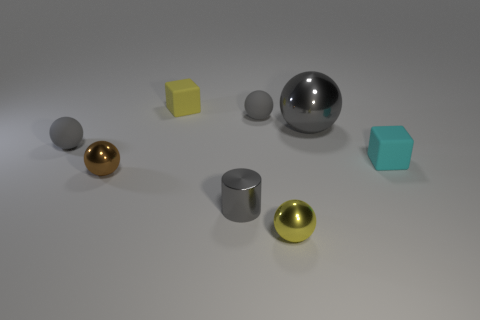What number of things are either large gray metal balls or tiny gray matte spheres that are in front of the gray shiny sphere?
Make the answer very short. 2. How many things are objects on the right side of the tiny brown metallic sphere or matte objects that are behind the big gray metallic thing?
Offer a terse response. 6. Are there any large shiny objects in front of the gray cylinder?
Make the answer very short. No. What is the color of the cube that is on the right side of the tiny matte sphere right of the shiny ball that is on the left side of the yellow rubber cube?
Offer a very short reply. Cyan. Is the shape of the small brown metallic thing the same as the small cyan object?
Provide a succinct answer. No. What color is the tiny cylinder that is made of the same material as the brown ball?
Make the answer very short. Gray. How many things are small blocks that are to the right of the tiny gray cylinder or small metal things?
Provide a succinct answer. 4. What size is the rubber block to the left of the large object?
Offer a terse response. Small. There is a gray shiny sphere; does it have the same size as the cylinder behind the tiny yellow shiny object?
Keep it short and to the point. No. There is a rubber object on the right side of the metallic thing behind the cyan rubber object; what color is it?
Ensure brevity in your answer.  Cyan. 